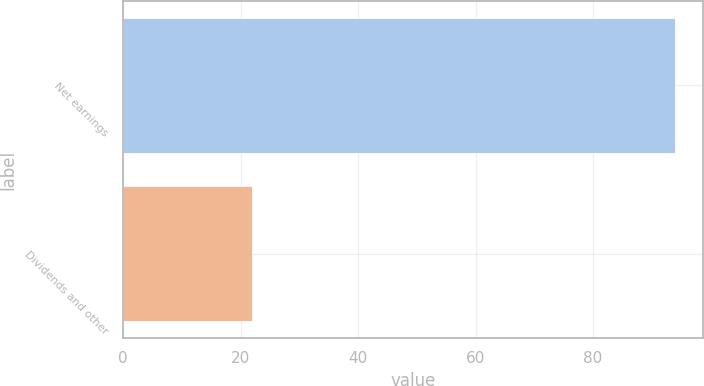Convert chart to OTSL. <chart><loc_0><loc_0><loc_500><loc_500><bar_chart><fcel>Net earnings<fcel>Dividends and other<nl><fcel>94<fcel>22<nl></chart> 